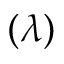<formula> <loc_0><loc_0><loc_500><loc_500>( \lambda )</formula> 